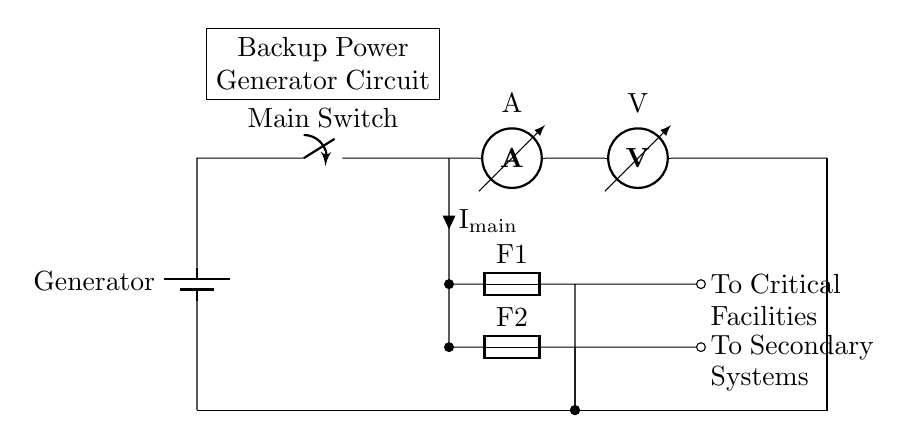What is the main power source in this circuit? The main power source is the generator, as indicated at the top of the circuit diagram labeled as "Generator".
Answer: Generator How many fuses are present in this circuit? The circuit contains two fuses, labeled as "F1" and "F2", which can be seen on the left side of the circuit after the main switch.
Answer: Two What is the role of the main switch? The main switch controls the connection between the generator and the rest of the circuit, allowing or interrupting the flow of electricity as needed.
Answer: Controls flow What is the current flowing through the main line labeled? The current flowing through the main line is labeled as I main and is shown in the circuit as flowing down from the switch to the components.
Answer: I main Where do the critical facilities connect in the circuit? The critical facilities connect after the ammeter and voltmeter, indicated by the connection labeled "To Critical Facilities".
Answer: To Critical Facilities Which components provide protective functions in this circuit? The components providing protective functions are the fuses (F1 and F2), which protect the circuit from overload by breaking the connection when excessive current flows.
Answer: Fuses 